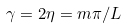<formula> <loc_0><loc_0><loc_500><loc_500>\gamma = 2 \eta = m \pi / L</formula> 